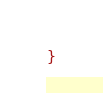<code> <loc_0><loc_0><loc_500><loc_500><_CSS_>}
</code> 